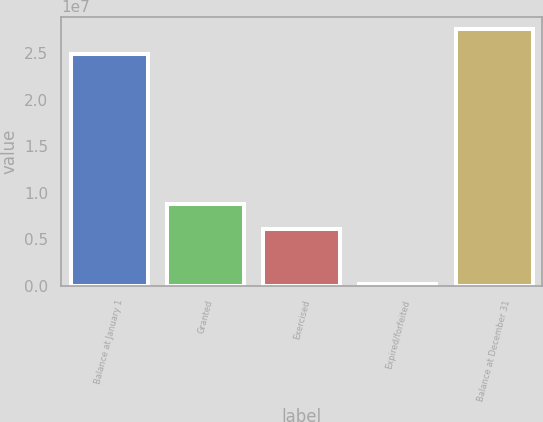Convert chart to OTSL. <chart><loc_0><loc_0><loc_500><loc_500><bar_chart><fcel>Balance at January 1<fcel>Granted<fcel>Exercised<fcel>Expired/forfeited<fcel>Balance at December 31<nl><fcel>2.49216e+07<fcel>8.75344e+06<fcel>6.08165e+06<fcel>212500<fcel>2.75934e+07<nl></chart> 